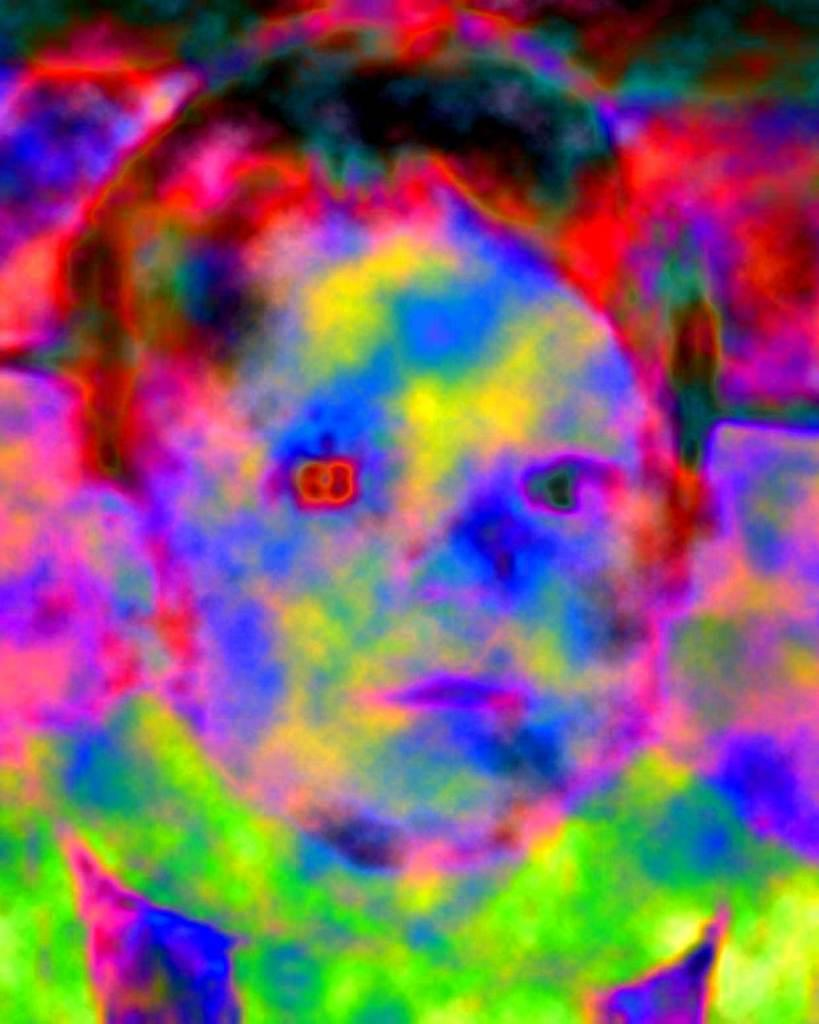What is depicted in the image? There is a painting of a child in the image. What type of pancake is the child holding in the painting? There is no pancake present in the painting; it depicts a child, not a pancake. 